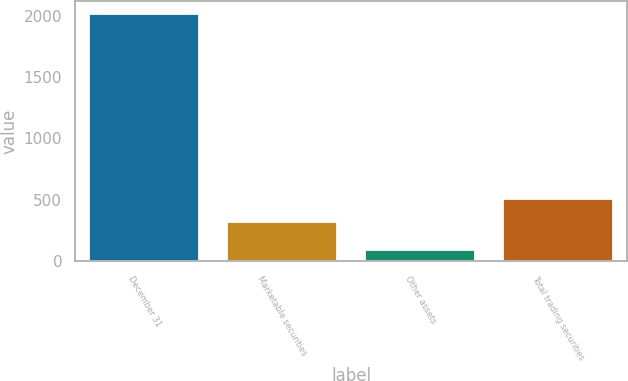Convert chart. <chart><loc_0><loc_0><loc_500><loc_500><bar_chart><fcel>December 31<fcel>Marketable securities<fcel>Other assets<fcel>Total trading securities<nl><fcel>2014<fcel>315<fcel>94<fcel>507<nl></chart> 